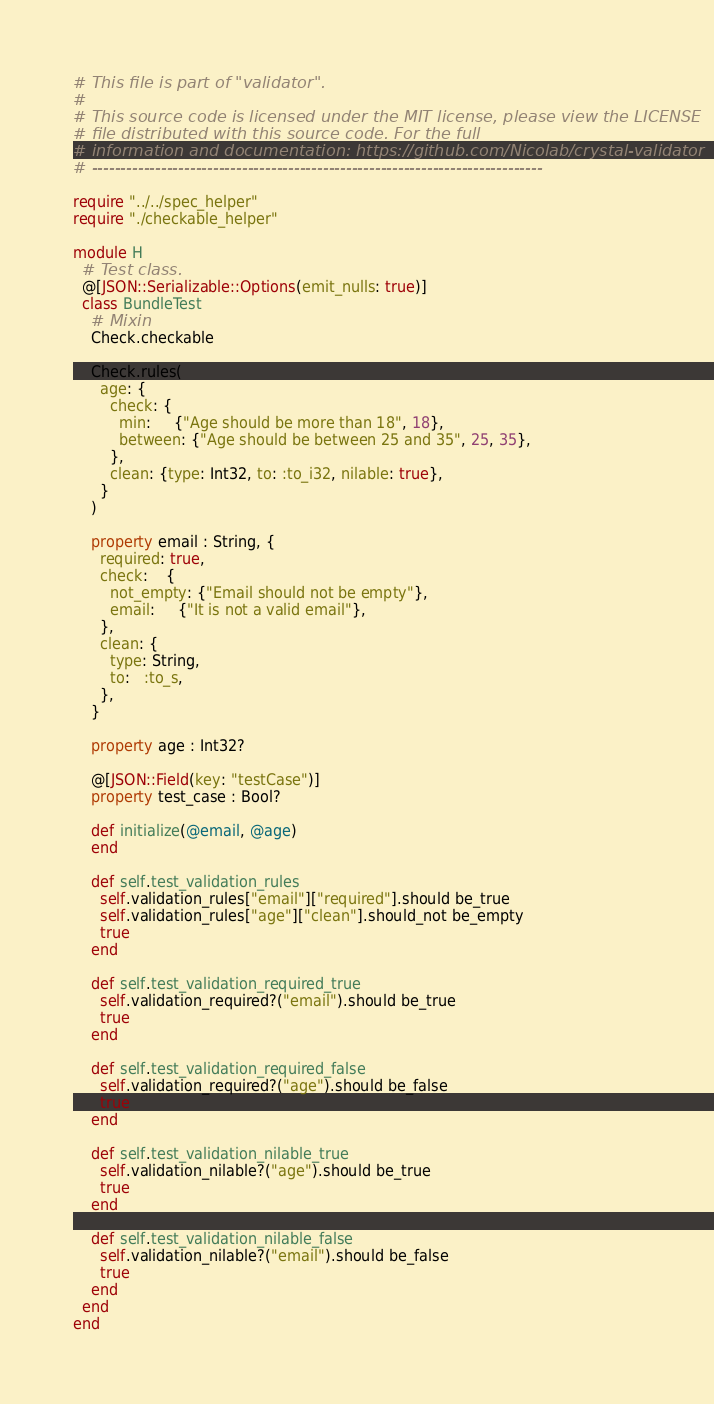<code> <loc_0><loc_0><loc_500><loc_500><_Crystal_># This file is part of "validator".
#
# This source code is licensed under the MIT license, please view the LICENSE
# file distributed with this source code. For the full
# information and documentation: https://github.com/Nicolab/crystal-validator
# ------------------------------------------------------------------------------

require "../../spec_helper"
require "./checkable_helper"

module H
  # Test class.
  @[JSON::Serializable::Options(emit_nulls: true)]
  class BundleTest
    # Mixin
    Check.checkable

    Check.rules(
      age: {
        check: {
          min:     {"Age should be more than 18", 18},
          between: {"Age should be between 25 and 35", 25, 35},
        },
        clean: {type: Int32, to: :to_i32, nilable: true},
      }
    )

    property email : String, {
      required: true,
      check:    {
        not_empty: {"Email should not be empty"},
        email:     {"It is not a valid email"},
      },
      clean: {
        type: String,
        to:   :to_s,
      },
    }

    property age : Int32?

    @[JSON::Field(key: "testCase")]
    property test_case : Bool?

    def initialize(@email, @age)
    end

    def self.test_validation_rules
      self.validation_rules["email"]["required"].should be_true
      self.validation_rules["age"]["clean"].should_not be_empty
      true
    end

    def self.test_validation_required_true
      self.validation_required?("email").should be_true
      true
    end

    def self.test_validation_required_false
      self.validation_required?("age").should be_false
      true
    end

    def self.test_validation_nilable_true
      self.validation_nilable?("age").should be_true
      true
    end

    def self.test_validation_nilable_false
      self.validation_nilable?("email").should be_false
      true
    end
  end
end
</code> 